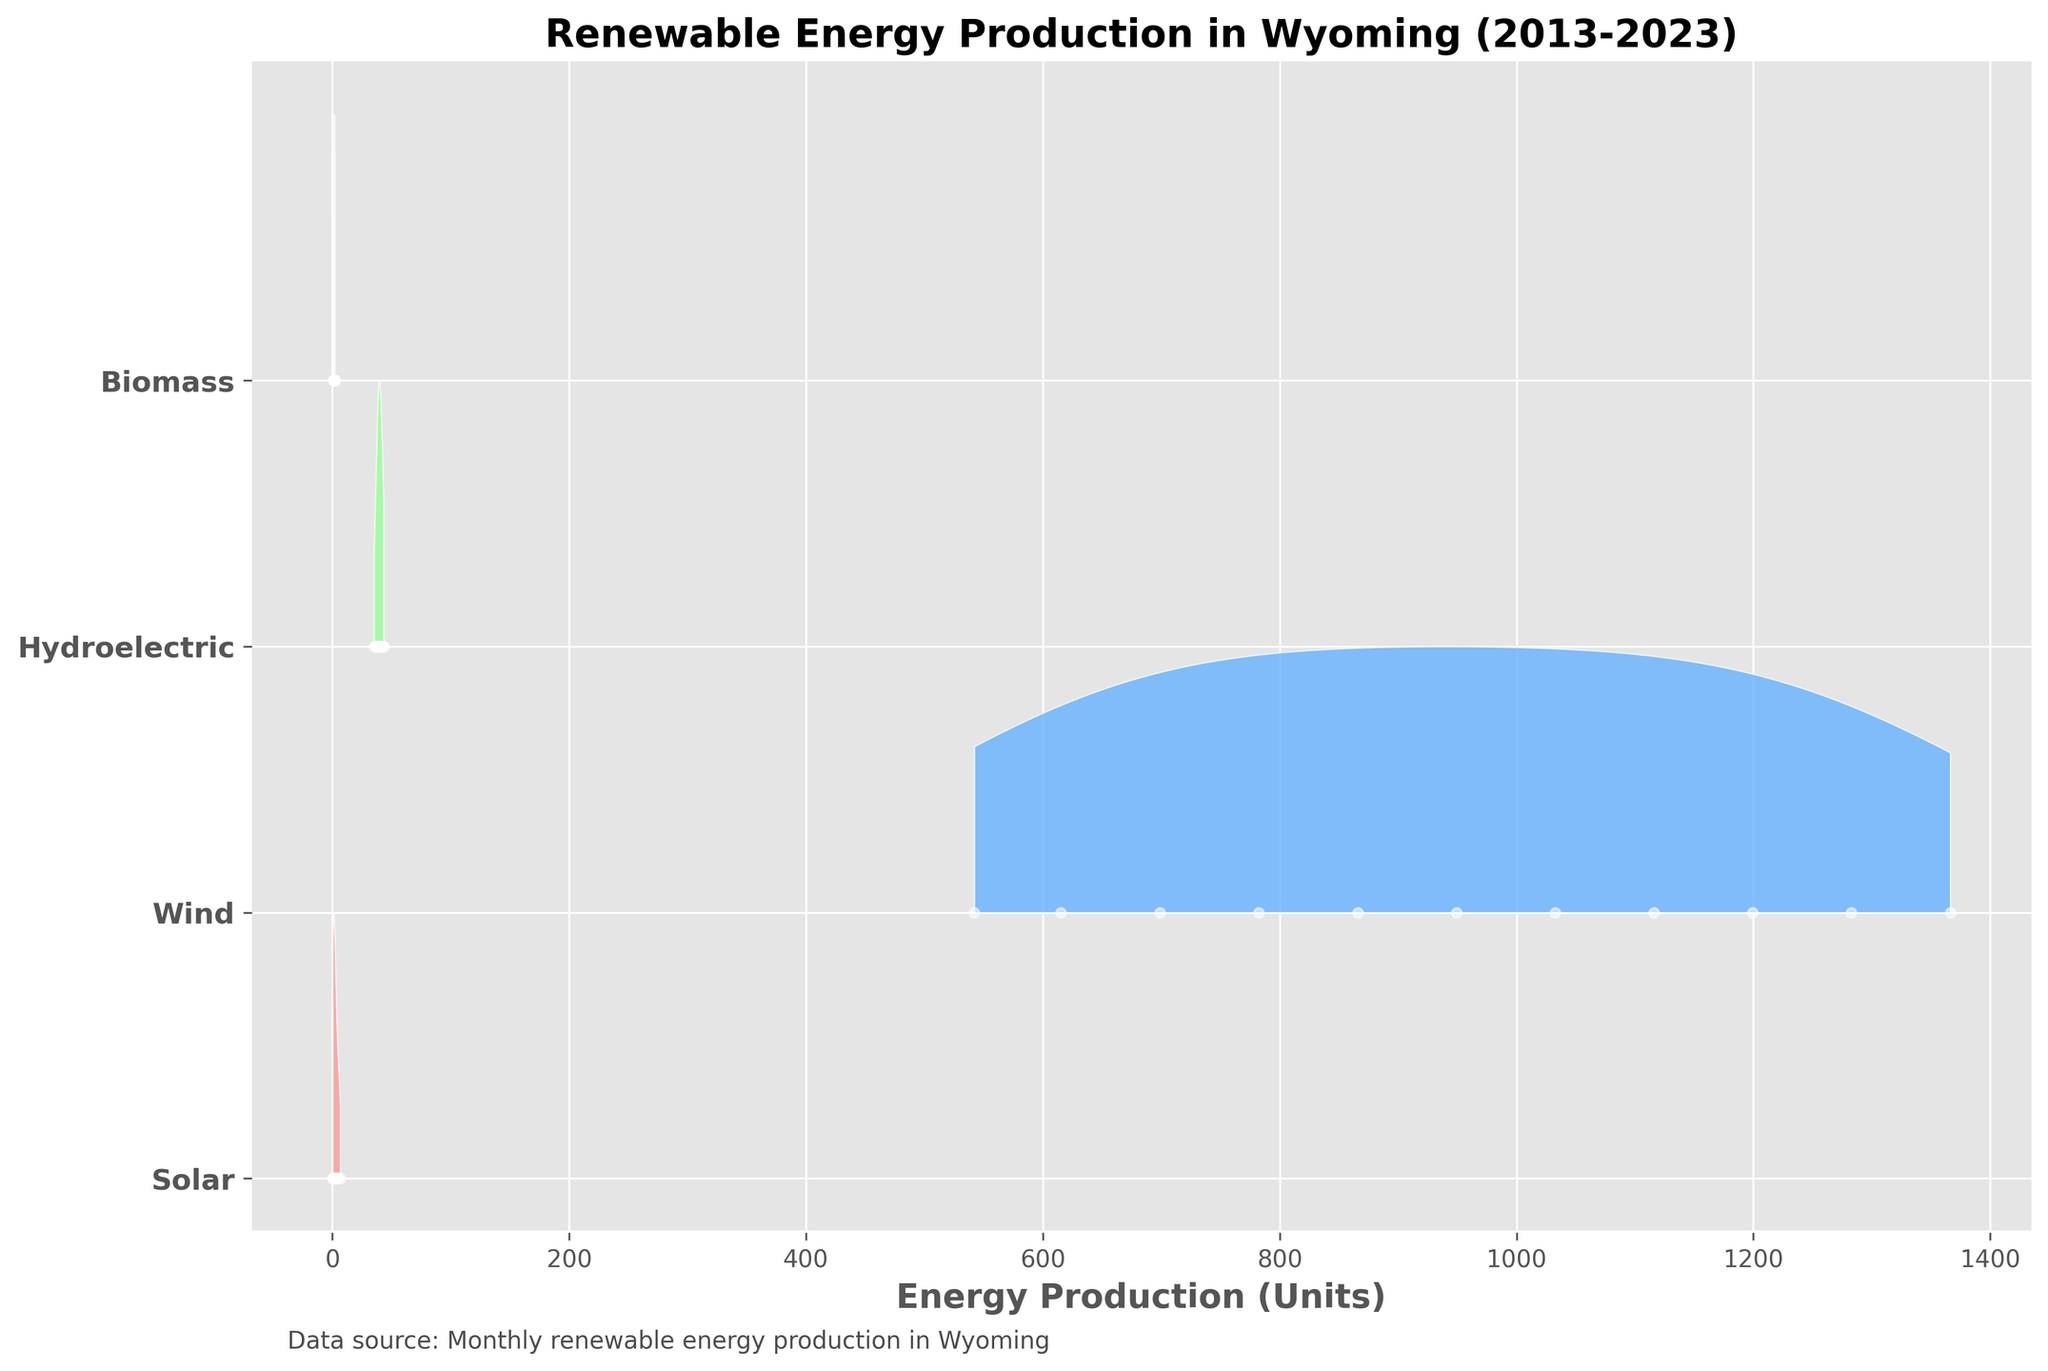What is the title of the plot? The title is usually placed at the top of the figure, and in this case, it reads "Renewable Energy Production in Wyoming (2013-2023)"
Answer: Renewable Energy Production in Wyoming (2013-2023) What are the four sources of renewable energy shown in the plot? The sources are identified by unique labels on the y-axis. Here, the four sources labeled are Solar, Wind, Hydroelectric, and Biomass
Answer: Solar, Wind, Hydroelectric, Biomass Which renewable energy source shows the highest production values? By examining the x-axis range and the density peaks, the Wind source consistently shows the highest production values compared to the others
Answer: Wind How does solar energy production change over the ten-year period? The density of Solar production increases and shows a clear upward trend, indicating higher values in more recent years
Answer: Upward trend Compared to Hydroelectric, how much more Wind energy was produced in January 2023? By looking at the line and density peak for January 2023, Wind production (1366.2) minus Hydroelectric production (43.2)
Answer: 1323 Which renewable energy source exhibits the least variation in production? The source with the narrowest density distribution across the years has the least variation. Biomass shows the least variation as it has a tight, consistent distribution
Answer: Biomass Is the production of renewable energy from Biomass increasing, decreasing, or stable? The density distribution for Biomass over the years remains relatively stable, showing minimal variation and no clear upward or downward trend
Answer: Stable How does the maximum Solar energy production in January 2023 compare to the same month's Wind production? By comparing the peak values in January 2023, Solar production is 6.5, and Wind production is 1366.2, so Solar is much lower
Answer: Solar is much lower On which source does the plot provide the highest colors (most visible density)? The plot provides the highest color density, indicating the most data points, around wind energy production
Answer: Wind What is the trend in Hydroelectric production from 2013 to 2023? The density distribution for Hydroelectric remains relatively steady with minor fluctuations, indicating no significant trend
Answer: Relatively steady 